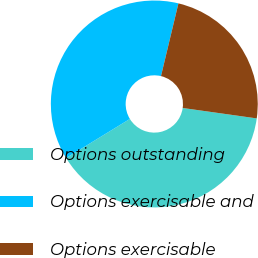<chart> <loc_0><loc_0><loc_500><loc_500><pie_chart><fcel>Options outstanding<fcel>Options exercisable and<fcel>Options exercisable<nl><fcel>39.02%<fcel>37.49%<fcel>23.48%<nl></chart> 